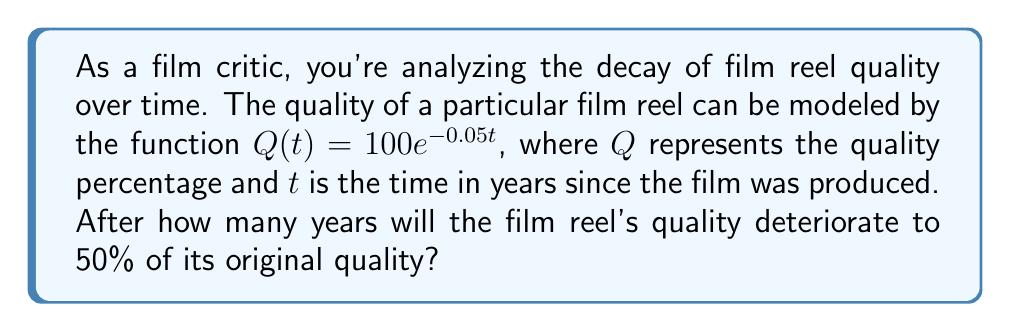Can you answer this question? To solve this problem, we need to use the given exponential decay function and determine when the quality reaches 50%. Let's approach this step-by-step:

1) The given function is $Q(t) = 100e^{-0.05t}$

2) We want to find $t$ when $Q(t) = 50$ (50% of the original quality)

3) Let's set up the equation:
   $50 = 100e^{-0.05t}$

4) Divide both sides by 100:
   $0.5 = e^{-0.05t}$

5) Take the natural logarithm of both sides:
   $\ln(0.5) = \ln(e^{-0.05t})$

6) Simplify the right side using the properties of logarithms:
   $\ln(0.5) = -0.05t$

7) Solve for $t$:
   $t = -\frac{\ln(0.5)}{0.05}$

8) Calculate the value:
   $t = -\frac{\ln(0.5)}{0.05} \approx 13.86$ years

Therefore, it will take approximately 13.86 years for the film reel's quality to deteriorate to 50% of its original quality.
Answer: $13.86$ years 